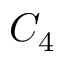Convert formula to latex. <formula><loc_0><loc_0><loc_500><loc_500>C _ { 4 }</formula> 